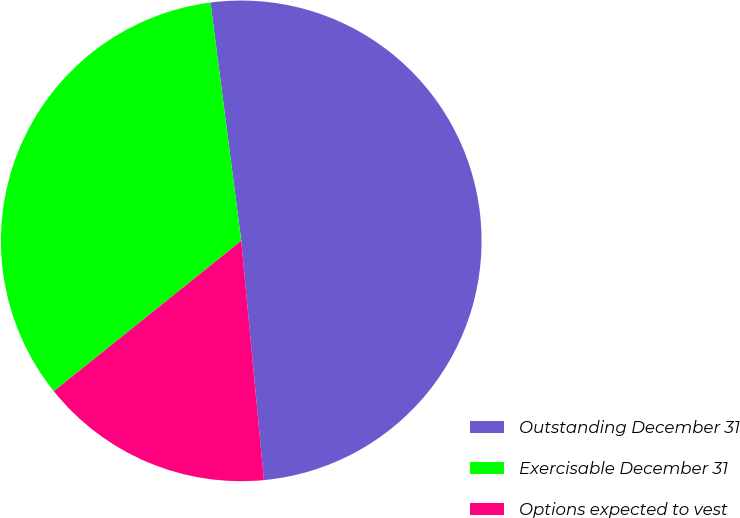Convert chart. <chart><loc_0><loc_0><loc_500><loc_500><pie_chart><fcel>Outstanding December 31<fcel>Exercisable December 31<fcel>Options expected to vest<nl><fcel>50.54%<fcel>33.72%<fcel>15.74%<nl></chart> 